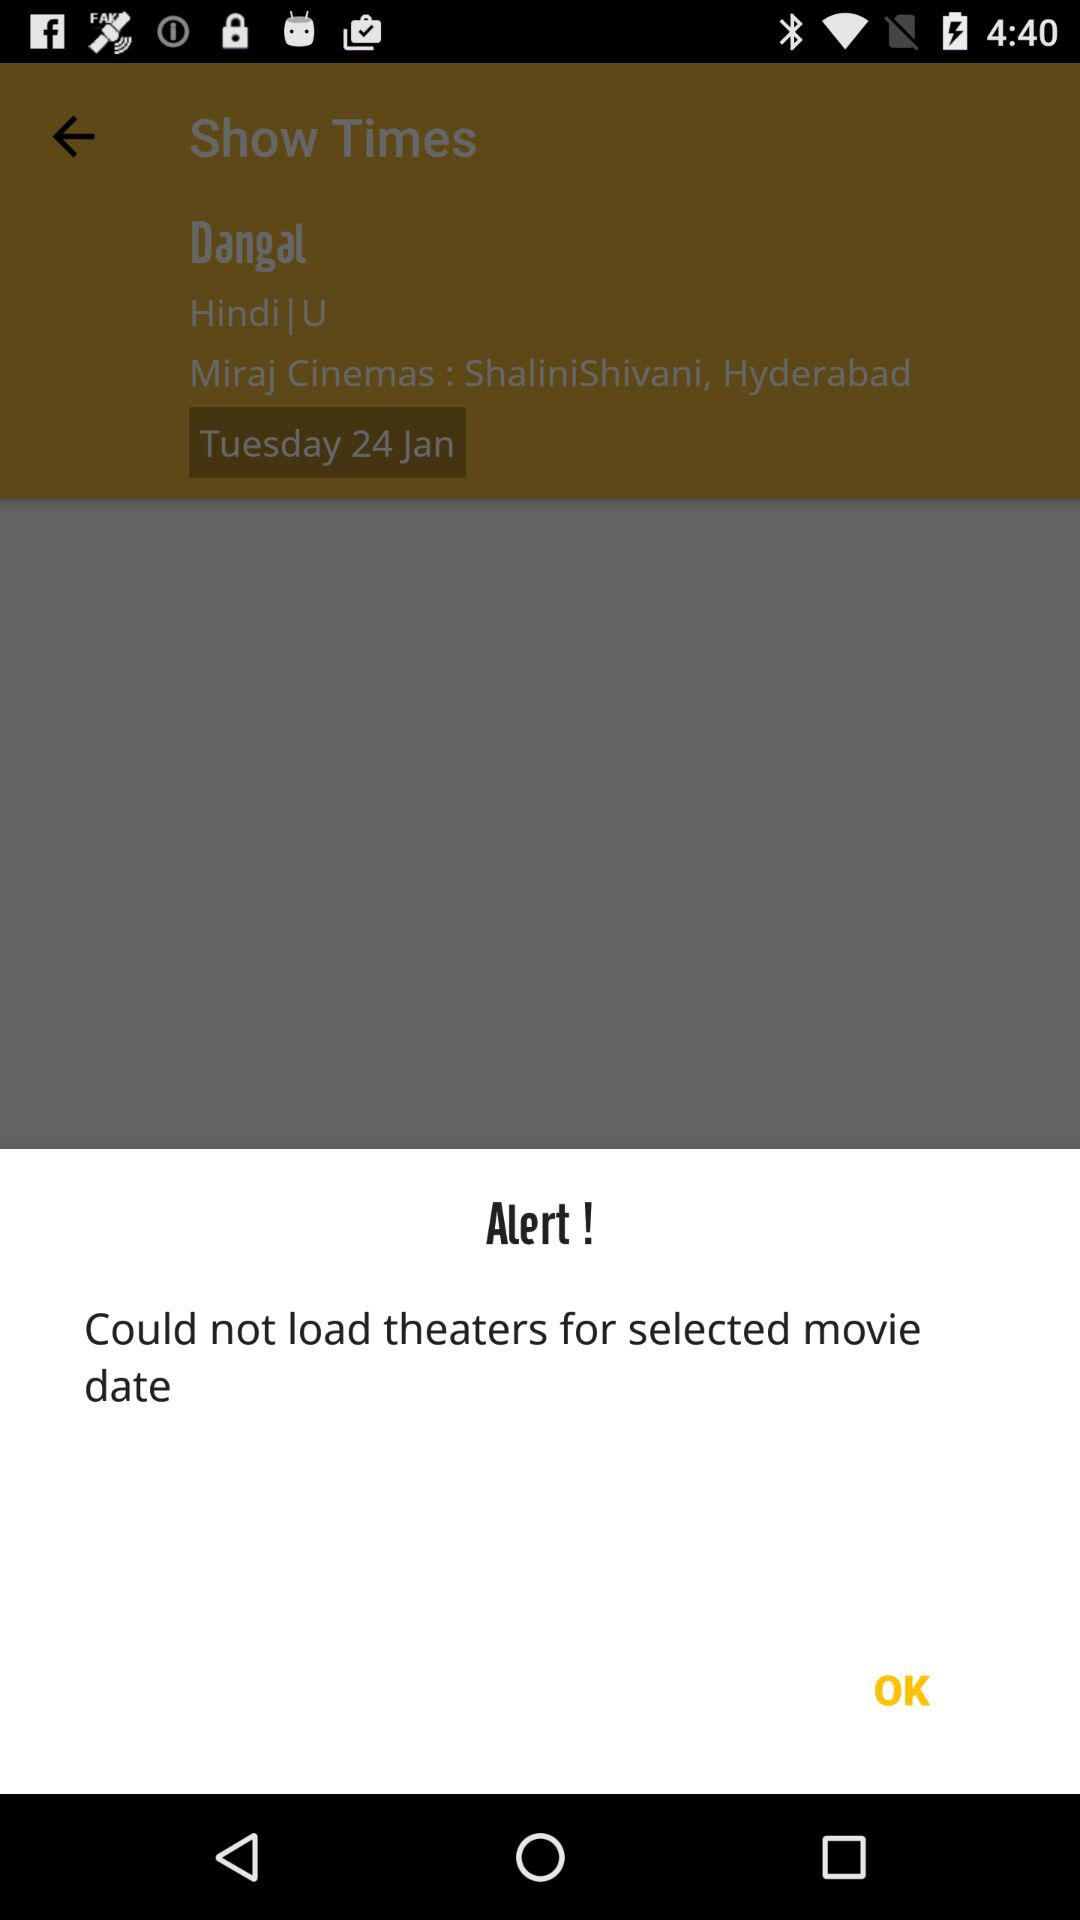What is the message that appears while loading theatres? The message is "Could not load theaters for selected movie date". 